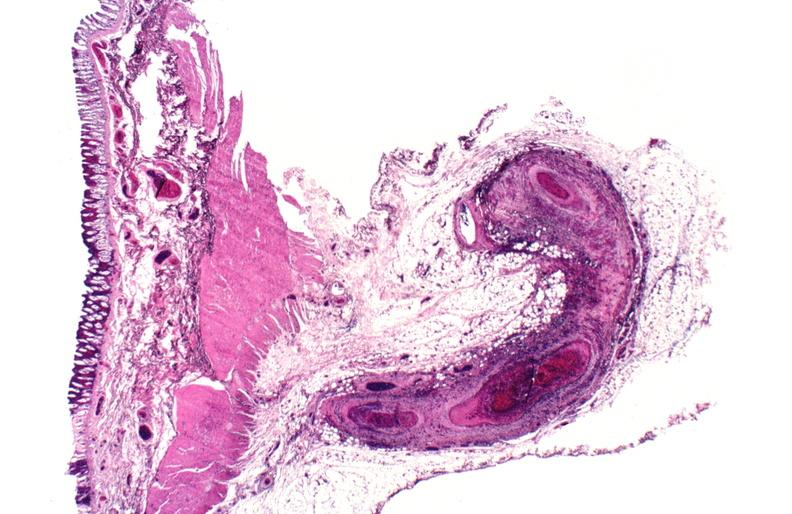s opened muscle present?
Answer the question using a single word or phrase. No 